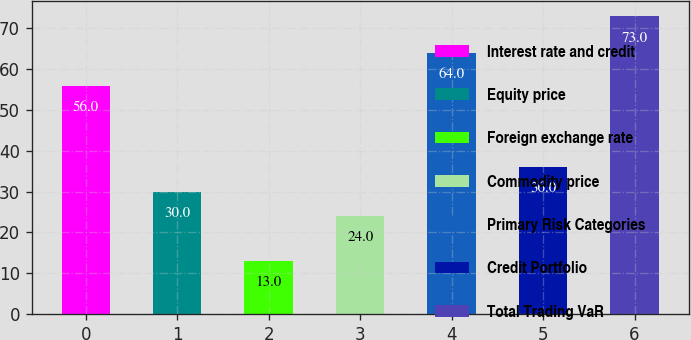Convert chart. <chart><loc_0><loc_0><loc_500><loc_500><bar_chart><fcel>Interest rate and credit<fcel>Equity price<fcel>Foreign exchange rate<fcel>Commodity price<fcel>Primary Risk Categories<fcel>Credit Portfolio<fcel>Total Trading VaR<nl><fcel>56<fcel>30<fcel>13<fcel>24<fcel>64<fcel>36<fcel>73<nl></chart> 